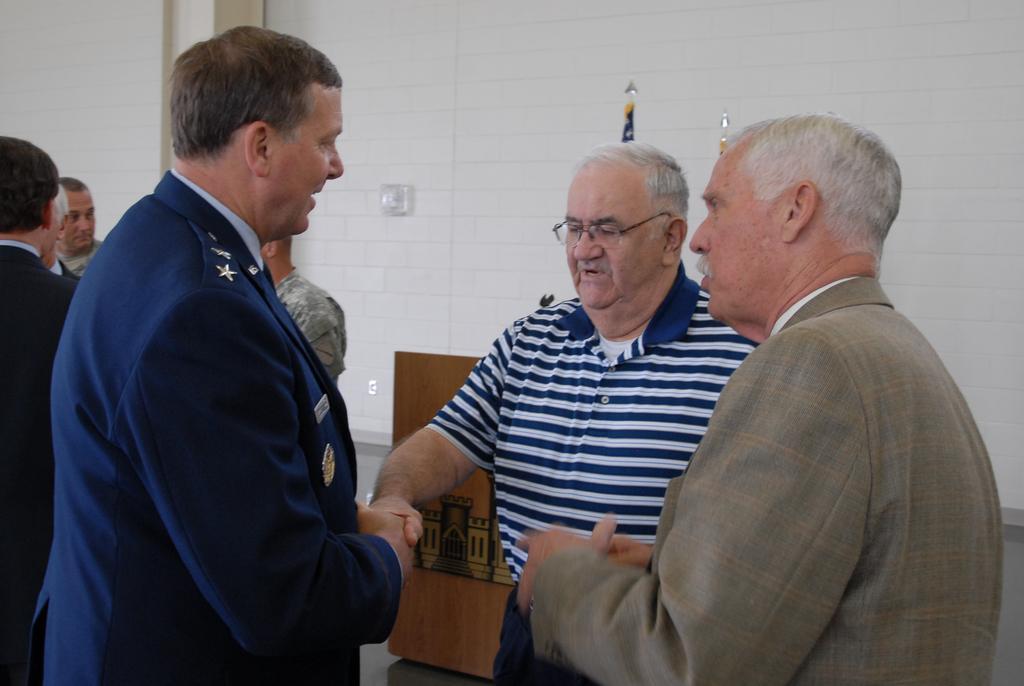How would you summarize this image in a sentence or two? In the image there are three men in the front shaking hands and behind them there are few men standing and over the back there is wall with a table in front of it and a switch board on it. 